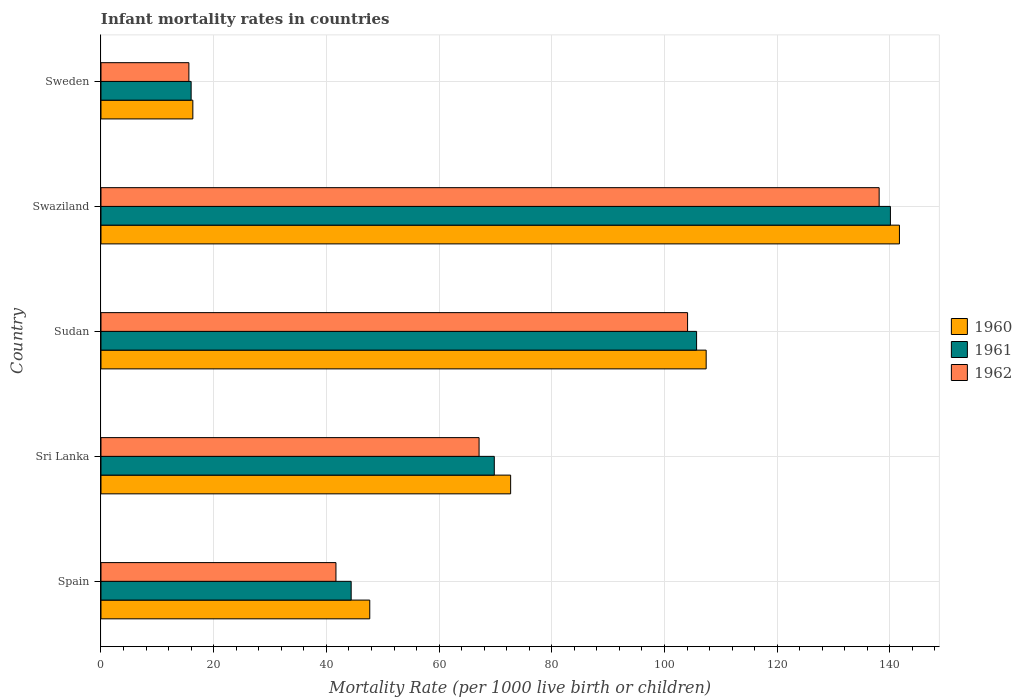Are the number of bars per tick equal to the number of legend labels?
Your answer should be compact. Yes. How many bars are there on the 3rd tick from the top?
Provide a short and direct response. 3. How many bars are there on the 4th tick from the bottom?
Offer a very short reply. 3. In how many cases, is the number of bars for a given country not equal to the number of legend labels?
Offer a terse response. 0. What is the infant mortality rate in 1961 in Sudan?
Offer a terse response. 105.7. Across all countries, what is the maximum infant mortality rate in 1961?
Ensure brevity in your answer.  140.1. Across all countries, what is the minimum infant mortality rate in 1962?
Provide a succinct answer. 15.6. In which country was the infant mortality rate in 1960 maximum?
Keep it short and to the point. Swaziland. In which country was the infant mortality rate in 1962 minimum?
Your answer should be very brief. Sweden. What is the total infant mortality rate in 1961 in the graph?
Your response must be concise. 376. What is the difference between the infant mortality rate in 1962 in Spain and that in Sudan?
Your answer should be compact. -62.4. What is the difference between the infant mortality rate in 1961 in Sudan and the infant mortality rate in 1962 in Sweden?
Keep it short and to the point. 90.1. What is the average infant mortality rate in 1962 per country?
Offer a terse response. 73.32. What is the difference between the infant mortality rate in 1961 and infant mortality rate in 1962 in Spain?
Offer a terse response. 2.7. In how many countries, is the infant mortality rate in 1960 greater than 104 ?
Provide a succinct answer. 2. What is the ratio of the infant mortality rate in 1962 in Sri Lanka to that in Sudan?
Ensure brevity in your answer.  0.64. Is the infant mortality rate in 1961 in Sri Lanka less than that in Sweden?
Provide a succinct answer. No. What is the difference between the highest and the second highest infant mortality rate in 1960?
Your response must be concise. 34.3. What is the difference between the highest and the lowest infant mortality rate in 1960?
Your answer should be compact. 125.4. In how many countries, is the infant mortality rate in 1962 greater than the average infant mortality rate in 1962 taken over all countries?
Ensure brevity in your answer.  2. What does the 2nd bar from the top in Swaziland represents?
Your answer should be compact. 1961. Is it the case that in every country, the sum of the infant mortality rate in 1962 and infant mortality rate in 1960 is greater than the infant mortality rate in 1961?
Provide a succinct answer. Yes. Are the values on the major ticks of X-axis written in scientific E-notation?
Offer a terse response. No. Does the graph contain grids?
Offer a terse response. Yes. Where does the legend appear in the graph?
Ensure brevity in your answer.  Center right. How are the legend labels stacked?
Your answer should be compact. Vertical. What is the title of the graph?
Offer a terse response. Infant mortality rates in countries. What is the label or title of the X-axis?
Offer a very short reply. Mortality Rate (per 1000 live birth or children). What is the Mortality Rate (per 1000 live birth or children) in 1960 in Spain?
Ensure brevity in your answer.  47.7. What is the Mortality Rate (per 1000 live birth or children) of 1961 in Spain?
Your answer should be compact. 44.4. What is the Mortality Rate (per 1000 live birth or children) of 1962 in Spain?
Your response must be concise. 41.7. What is the Mortality Rate (per 1000 live birth or children) of 1960 in Sri Lanka?
Your answer should be compact. 72.7. What is the Mortality Rate (per 1000 live birth or children) in 1961 in Sri Lanka?
Provide a short and direct response. 69.8. What is the Mortality Rate (per 1000 live birth or children) of 1962 in Sri Lanka?
Make the answer very short. 67.1. What is the Mortality Rate (per 1000 live birth or children) in 1960 in Sudan?
Make the answer very short. 107.4. What is the Mortality Rate (per 1000 live birth or children) in 1961 in Sudan?
Your answer should be compact. 105.7. What is the Mortality Rate (per 1000 live birth or children) of 1962 in Sudan?
Your response must be concise. 104.1. What is the Mortality Rate (per 1000 live birth or children) in 1960 in Swaziland?
Your answer should be very brief. 141.7. What is the Mortality Rate (per 1000 live birth or children) of 1961 in Swaziland?
Make the answer very short. 140.1. What is the Mortality Rate (per 1000 live birth or children) of 1962 in Swaziland?
Your answer should be compact. 138.1. What is the Mortality Rate (per 1000 live birth or children) in 1960 in Sweden?
Offer a terse response. 16.3. What is the Mortality Rate (per 1000 live birth or children) in 1961 in Sweden?
Make the answer very short. 16. What is the Mortality Rate (per 1000 live birth or children) in 1962 in Sweden?
Provide a succinct answer. 15.6. Across all countries, what is the maximum Mortality Rate (per 1000 live birth or children) of 1960?
Give a very brief answer. 141.7. Across all countries, what is the maximum Mortality Rate (per 1000 live birth or children) of 1961?
Your response must be concise. 140.1. Across all countries, what is the maximum Mortality Rate (per 1000 live birth or children) in 1962?
Give a very brief answer. 138.1. Across all countries, what is the minimum Mortality Rate (per 1000 live birth or children) in 1962?
Your answer should be compact. 15.6. What is the total Mortality Rate (per 1000 live birth or children) in 1960 in the graph?
Your answer should be compact. 385.8. What is the total Mortality Rate (per 1000 live birth or children) in 1961 in the graph?
Ensure brevity in your answer.  376. What is the total Mortality Rate (per 1000 live birth or children) in 1962 in the graph?
Provide a short and direct response. 366.6. What is the difference between the Mortality Rate (per 1000 live birth or children) in 1960 in Spain and that in Sri Lanka?
Your answer should be very brief. -25. What is the difference between the Mortality Rate (per 1000 live birth or children) of 1961 in Spain and that in Sri Lanka?
Make the answer very short. -25.4. What is the difference between the Mortality Rate (per 1000 live birth or children) of 1962 in Spain and that in Sri Lanka?
Your answer should be very brief. -25.4. What is the difference between the Mortality Rate (per 1000 live birth or children) of 1960 in Spain and that in Sudan?
Your response must be concise. -59.7. What is the difference between the Mortality Rate (per 1000 live birth or children) in 1961 in Spain and that in Sudan?
Provide a succinct answer. -61.3. What is the difference between the Mortality Rate (per 1000 live birth or children) of 1962 in Spain and that in Sudan?
Your answer should be very brief. -62.4. What is the difference between the Mortality Rate (per 1000 live birth or children) in 1960 in Spain and that in Swaziland?
Make the answer very short. -94. What is the difference between the Mortality Rate (per 1000 live birth or children) in 1961 in Spain and that in Swaziland?
Keep it short and to the point. -95.7. What is the difference between the Mortality Rate (per 1000 live birth or children) in 1962 in Spain and that in Swaziland?
Offer a terse response. -96.4. What is the difference between the Mortality Rate (per 1000 live birth or children) of 1960 in Spain and that in Sweden?
Provide a short and direct response. 31.4. What is the difference between the Mortality Rate (per 1000 live birth or children) of 1961 in Spain and that in Sweden?
Your answer should be very brief. 28.4. What is the difference between the Mortality Rate (per 1000 live birth or children) in 1962 in Spain and that in Sweden?
Make the answer very short. 26.1. What is the difference between the Mortality Rate (per 1000 live birth or children) of 1960 in Sri Lanka and that in Sudan?
Offer a terse response. -34.7. What is the difference between the Mortality Rate (per 1000 live birth or children) in 1961 in Sri Lanka and that in Sudan?
Your response must be concise. -35.9. What is the difference between the Mortality Rate (per 1000 live birth or children) of 1962 in Sri Lanka and that in Sudan?
Provide a short and direct response. -37. What is the difference between the Mortality Rate (per 1000 live birth or children) of 1960 in Sri Lanka and that in Swaziland?
Your response must be concise. -69. What is the difference between the Mortality Rate (per 1000 live birth or children) in 1961 in Sri Lanka and that in Swaziland?
Your answer should be compact. -70.3. What is the difference between the Mortality Rate (per 1000 live birth or children) of 1962 in Sri Lanka and that in Swaziland?
Offer a very short reply. -71. What is the difference between the Mortality Rate (per 1000 live birth or children) of 1960 in Sri Lanka and that in Sweden?
Make the answer very short. 56.4. What is the difference between the Mortality Rate (per 1000 live birth or children) of 1961 in Sri Lanka and that in Sweden?
Offer a terse response. 53.8. What is the difference between the Mortality Rate (per 1000 live birth or children) of 1962 in Sri Lanka and that in Sweden?
Keep it short and to the point. 51.5. What is the difference between the Mortality Rate (per 1000 live birth or children) of 1960 in Sudan and that in Swaziland?
Your response must be concise. -34.3. What is the difference between the Mortality Rate (per 1000 live birth or children) in 1961 in Sudan and that in Swaziland?
Provide a succinct answer. -34.4. What is the difference between the Mortality Rate (per 1000 live birth or children) in 1962 in Sudan and that in Swaziland?
Your answer should be very brief. -34. What is the difference between the Mortality Rate (per 1000 live birth or children) of 1960 in Sudan and that in Sweden?
Give a very brief answer. 91.1. What is the difference between the Mortality Rate (per 1000 live birth or children) of 1961 in Sudan and that in Sweden?
Your answer should be compact. 89.7. What is the difference between the Mortality Rate (per 1000 live birth or children) in 1962 in Sudan and that in Sweden?
Give a very brief answer. 88.5. What is the difference between the Mortality Rate (per 1000 live birth or children) of 1960 in Swaziland and that in Sweden?
Your response must be concise. 125.4. What is the difference between the Mortality Rate (per 1000 live birth or children) of 1961 in Swaziland and that in Sweden?
Keep it short and to the point. 124.1. What is the difference between the Mortality Rate (per 1000 live birth or children) in 1962 in Swaziland and that in Sweden?
Provide a short and direct response. 122.5. What is the difference between the Mortality Rate (per 1000 live birth or children) in 1960 in Spain and the Mortality Rate (per 1000 live birth or children) in 1961 in Sri Lanka?
Your answer should be very brief. -22.1. What is the difference between the Mortality Rate (per 1000 live birth or children) of 1960 in Spain and the Mortality Rate (per 1000 live birth or children) of 1962 in Sri Lanka?
Your answer should be compact. -19.4. What is the difference between the Mortality Rate (per 1000 live birth or children) of 1961 in Spain and the Mortality Rate (per 1000 live birth or children) of 1962 in Sri Lanka?
Offer a terse response. -22.7. What is the difference between the Mortality Rate (per 1000 live birth or children) in 1960 in Spain and the Mortality Rate (per 1000 live birth or children) in 1961 in Sudan?
Offer a terse response. -58. What is the difference between the Mortality Rate (per 1000 live birth or children) in 1960 in Spain and the Mortality Rate (per 1000 live birth or children) in 1962 in Sudan?
Make the answer very short. -56.4. What is the difference between the Mortality Rate (per 1000 live birth or children) in 1961 in Spain and the Mortality Rate (per 1000 live birth or children) in 1962 in Sudan?
Offer a very short reply. -59.7. What is the difference between the Mortality Rate (per 1000 live birth or children) of 1960 in Spain and the Mortality Rate (per 1000 live birth or children) of 1961 in Swaziland?
Offer a terse response. -92.4. What is the difference between the Mortality Rate (per 1000 live birth or children) of 1960 in Spain and the Mortality Rate (per 1000 live birth or children) of 1962 in Swaziland?
Provide a short and direct response. -90.4. What is the difference between the Mortality Rate (per 1000 live birth or children) in 1961 in Spain and the Mortality Rate (per 1000 live birth or children) in 1962 in Swaziland?
Keep it short and to the point. -93.7. What is the difference between the Mortality Rate (per 1000 live birth or children) of 1960 in Spain and the Mortality Rate (per 1000 live birth or children) of 1961 in Sweden?
Offer a very short reply. 31.7. What is the difference between the Mortality Rate (per 1000 live birth or children) of 1960 in Spain and the Mortality Rate (per 1000 live birth or children) of 1962 in Sweden?
Your response must be concise. 32.1. What is the difference between the Mortality Rate (per 1000 live birth or children) of 1961 in Spain and the Mortality Rate (per 1000 live birth or children) of 1962 in Sweden?
Offer a terse response. 28.8. What is the difference between the Mortality Rate (per 1000 live birth or children) of 1960 in Sri Lanka and the Mortality Rate (per 1000 live birth or children) of 1961 in Sudan?
Provide a short and direct response. -33. What is the difference between the Mortality Rate (per 1000 live birth or children) of 1960 in Sri Lanka and the Mortality Rate (per 1000 live birth or children) of 1962 in Sudan?
Offer a terse response. -31.4. What is the difference between the Mortality Rate (per 1000 live birth or children) in 1961 in Sri Lanka and the Mortality Rate (per 1000 live birth or children) in 1962 in Sudan?
Your answer should be very brief. -34.3. What is the difference between the Mortality Rate (per 1000 live birth or children) in 1960 in Sri Lanka and the Mortality Rate (per 1000 live birth or children) in 1961 in Swaziland?
Your response must be concise. -67.4. What is the difference between the Mortality Rate (per 1000 live birth or children) in 1960 in Sri Lanka and the Mortality Rate (per 1000 live birth or children) in 1962 in Swaziland?
Provide a succinct answer. -65.4. What is the difference between the Mortality Rate (per 1000 live birth or children) in 1961 in Sri Lanka and the Mortality Rate (per 1000 live birth or children) in 1962 in Swaziland?
Your response must be concise. -68.3. What is the difference between the Mortality Rate (per 1000 live birth or children) of 1960 in Sri Lanka and the Mortality Rate (per 1000 live birth or children) of 1961 in Sweden?
Provide a succinct answer. 56.7. What is the difference between the Mortality Rate (per 1000 live birth or children) in 1960 in Sri Lanka and the Mortality Rate (per 1000 live birth or children) in 1962 in Sweden?
Provide a succinct answer. 57.1. What is the difference between the Mortality Rate (per 1000 live birth or children) in 1961 in Sri Lanka and the Mortality Rate (per 1000 live birth or children) in 1962 in Sweden?
Offer a terse response. 54.2. What is the difference between the Mortality Rate (per 1000 live birth or children) of 1960 in Sudan and the Mortality Rate (per 1000 live birth or children) of 1961 in Swaziland?
Your response must be concise. -32.7. What is the difference between the Mortality Rate (per 1000 live birth or children) in 1960 in Sudan and the Mortality Rate (per 1000 live birth or children) in 1962 in Swaziland?
Provide a short and direct response. -30.7. What is the difference between the Mortality Rate (per 1000 live birth or children) of 1961 in Sudan and the Mortality Rate (per 1000 live birth or children) of 1962 in Swaziland?
Keep it short and to the point. -32.4. What is the difference between the Mortality Rate (per 1000 live birth or children) in 1960 in Sudan and the Mortality Rate (per 1000 live birth or children) in 1961 in Sweden?
Ensure brevity in your answer.  91.4. What is the difference between the Mortality Rate (per 1000 live birth or children) of 1960 in Sudan and the Mortality Rate (per 1000 live birth or children) of 1962 in Sweden?
Offer a very short reply. 91.8. What is the difference between the Mortality Rate (per 1000 live birth or children) of 1961 in Sudan and the Mortality Rate (per 1000 live birth or children) of 1962 in Sweden?
Your answer should be very brief. 90.1. What is the difference between the Mortality Rate (per 1000 live birth or children) in 1960 in Swaziland and the Mortality Rate (per 1000 live birth or children) in 1961 in Sweden?
Offer a very short reply. 125.7. What is the difference between the Mortality Rate (per 1000 live birth or children) in 1960 in Swaziland and the Mortality Rate (per 1000 live birth or children) in 1962 in Sweden?
Provide a succinct answer. 126.1. What is the difference between the Mortality Rate (per 1000 live birth or children) of 1961 in Swaziland and the Mortality Rate (per 1000 live birth or children) of 1962 in Sweden?
Your answer should be very brief. 124.5. What is the average Mortality Rate (per 1000 live birth or children) in 1960 per country?
Make the answer very short. 77.16. What is the average Mortality Rate (per 1000 live birth or children) of 1961 per country?
Offer a terse response. 75.2. What is the average Mortality Rate (per 1000 live birth or children) of 1962 per country?
Provide a short and direct response. 73.32. What is the difference between the Mortality Rate (per 1000 live birth or children) of 1960 and Mortality Rate (per 1000 live birth or children) of 1961 in Spain?
Provide a short and direct response. 3.3. What is the difference between the Mortality Rate (per 1000 live birth or children) in 1960 and Mortality Rate (per 1000 live birth or children) in 1962 in Spain?
Ensure brevity in your answer.  6. What is the difference between the Mortality Rate (per 1000 live birth or children) in 1960 and Mortality Rate (per 1000 live birth or children) in 1961 in Sri Lanka?
Offer a very short reply. 2.9. What is the difference between the Mortality Rate (per 1000 live birth or children) of 1960 and Mortality Rate (per 1000 live birth or children) of 1962 in Sri Lanka?
Keep it short and to the point. 5.6. What is the difference between the Mortality Rate (per 1000 live birth or children) of 1960 and Mortality Rate (per 1000 live birth or children) of 1962 in Sudan?
Offer a very short reply. 3.3. What is the difference between the Mortality Rate (per 1000 live birth or children) of 1961 and Mortality Rate (per 1000 live birth or children) of 1962 in Sudan?
Ensure brevity in your answer.  1.6. What is the difference between the Mortality Rate (per 1000 live birth or children) in 1960 and Mortality Rate (per 1000 live birth or children) in 1961 in Swaziland?
Your response must be concise. 1.6. What is the difference between the Mortality Rate (per 1000 live birth or children) of 1960 and Mortality Rate (per 1000 live birth or children) of 1962 in Swaziland?
Give a very brief answer. 3.6. What is the difference between the Mortality Rate (per 1000 live birth or children) of 1961 and Mortality Rate (per 1000 live birth or children) of 1962 in Swaziland?
Keep it short and to the point. 2. What is the difference between the Mortality Rate (per 1000 live birth or children) of 1960 and Mortality Rate (per 1000 live birth or children) of 1961 in Sweden?
Offer a very short reply. 0.3. What is the difference between the Mortality Rate (per 1000 live birth or children) in 1960 and Mortality Rate (per 1000 live birth or children) in 1962 in Sweden?
Make the answer very short. 0.7. What is the difference between the Mortality Rate (per 1000 live birth or children) of 1961 and Mortality Rate (per 1000 live birth or children) of 1962 in Sweden?
Your answer should be very brief. 0.4. What is the ratio of the Mortality Rate (per 1000 live birth or children) of 1960 in Spain to that in Sri Lanka?
Keep it short and to the point. 0.66. What is the ratio of the Mortality Rate (per 1000 live birth or children) in 1961 in Spain to that in Sri Lanka?
Offer a very short reply. 0.64. What is the ratio of the Mortality Rate (per 1000 live birth or children) of 1962 in Spain to that in Sri Lanka?
Your response must be concise. 0.62. What is the ratio of the Mortality Rate (per 1000 live birth or children) in 1960 in Spain to that in Sudan?
Your answer should be compact. 0.44. What is the ratio of the Mortality Rate (per 1000 live birth or children) of 1961 in Spain to that in Sudan?
Ensure brevity in your answer.  0.42. What is the ratio of the Mortality Rate (per 1000 live birth or children) in 1962 in Spain to that in Sudan?
Ensure brevity in your answer.  0.4. What is the ratio of the Mortality Rate (per 1000 live birth or children) in 1960 in Spain to that in Swaziland?
Your answer should be compact. 0.34. What is the ratio of the Mortality Rate (per 1000 live birth or children) in 1961 in Spain to that in Swaziland?
Provide a short and direct response. 0.32. What is the ratio of the Mortality Rate (per 1000 live birth or children) of 1962 in Spain to that in Swaziland?
Offer a very short reply. 0.3. What is the ratio of the Mortality Rate (per 1000 live birth or children) in 1960 in Spain to that in Sweden?
Your answer should be very brief. 2.93. What is the ratio of the Mortality Rate (per 1000 live birth or children) of 1961 in Spain to that in Sweden?
Give a very brief answer. 2.77. What is the ratio of the Mortality Rate (per 1000 live birth or children) in 1962 in Spain to that in Sweden?
Make the answer very short. 2.67. What is the ratio of the Mortality Rate (per 1000 live birth or children) of 1960 in Sri Lanka to that in Sudan?
Keep it short and to the point. 0.68. What is the ratio of the Mortality Rate (per 1000 live birth or children) of 1961 in Sri Lanka to that in Sudan?
Ensure brevity in your answer.  0.66. What is the ratio of the Mortality Rate (per 1000 live birth or children) in 1962 in Sri Lanka to that in Sudan?
Offer a terse response. 0.64. What is the ratio of the Mortality Rate (per 1000 live birth or children) of 1960 in Sri Lanka to that in Swaziland?
Give a very brief answer. 0.51. What is the ratio of the Mortality Rate (per 1000 live birth or children) in 1961 in Sri Lanka to that in Swaziland?
Keep it short and to the point. 0.5. What is the ratio of the Mortality Rate (per 1000 live birth or children) in 1962 in Sri Lanka to that in Swaziland?
Make the answer very short. 0.49. What is the ratio of the Mortality Rate (per 1000 live birth or children) of 1960 in Sri Lanka to that in Sweden?
Provide a succinct answer. 4.46. What is the ratio of the Mortality Rate (per 1000 live birth or children) of 1961 in Sri Lanka to that in Sweden?
Make the answer very short. 4.36. What is the ratio of the Mortality Rate (per 1000 live birth or children) of 1962 in Sri Lanka to that in Sweden?
Make the answer very short. 4.3. What is the ratio of the Mortality Rate (per 1000 live birth or children) in 1960 in Sudan to that in Swaziland?
Make the answer very short. 0.76. What is the ratio of the Mortality Rate (per 1000 live birth or children) in 1961 in Sudan to that in Swaziland?
Ensure brevity in your answer.  0.75. What is the ratio of the Mortality Rate (per 1000 live birth or children) in 1962 in Sudan to that in Swaziland?
Your response must be concise. 0.75. What is the ratio of the Mortality Rate (per 1000 live birth or children) of 1960 in Sudan to that in Sweden?
Your answer should be compact. 6.59. What is the ratio of the Mortality Rate (per 1000 live birth or children) of 1961 in Sudan to that in Sweden?
Offer a very short reply. 6.61. What is the ratio of the Mortality Rate (per 1000 live birth or children) in 1962 in Sudan to that in Sweden?
Provide a succinct answer. 6.67. What is the ratio of the Mortality Rate (per 1000 live birth or children) in 1960 in Swaziland to that in Sweden?
Your answer should be compact. 8.69. What is the ratio of the Mortality Rate (per 1000 live birth or children) of 1961 in Swaziland to that in Sweden?
Offer a terse response. 8.76. What is the ratio of the Mortality Rate (per 1000 live birth or children) in 1962 in Swaziland to that in Sweden?
Provide a short and direct response. 8.85. What is the difference between the highest and the second highest Mortality Rate (per 1000 live birth or children) of 1960?
Offer a very short reply. 34.3. What is the difference between the highest and the second highest Mortality Rate (per 1000 live birth or children) of 1961?
Provide a short and direct response. 34.4. What is the difference between the highest and the lowest Mortality Rate (per 1000 live birth or children) of 1960?
Ensure brevity in your answer.  125.4. What is the difference between the highest and the lowest Mortality Rate (per 1000 live birth or children) in 1961?
Make the answer very short. 124.1. What is the difference between the highest and the lowest Mortality Rate (per 1000 live birth or children) in 1962?
Give a very brief answer. 122.5. 